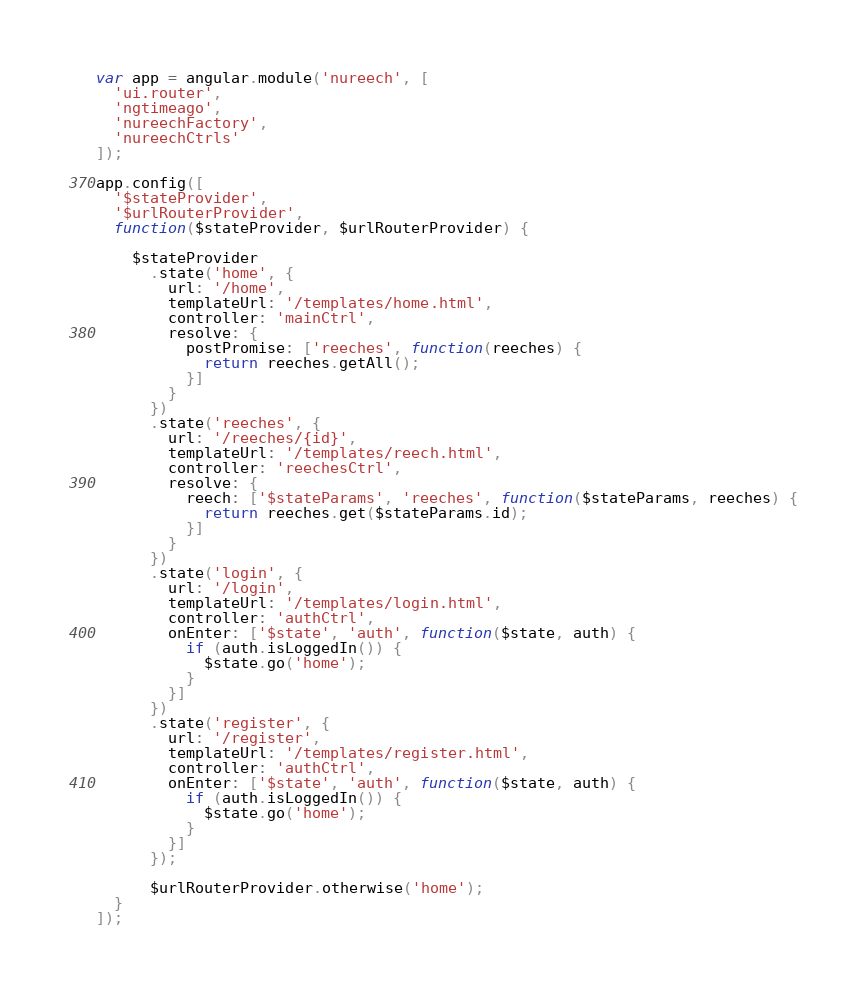Convert code to text. <code><loc_0><loc_0><loc_500><loc_500><_JavaScript_>var app = angular.module('nureech', [
  'ui.router',
  'ngtimeago',
  'nureechFactory',
  'nureechCtrls'
]);

app.config([
  '$stateProvider',
  '$urlRouterProvider',
  function($stateProvider, $urlRouterProvider) {

    $stateProvider
      .state('home', {
        url: '/home',
        templateUrl: '/templates/home.html',
        controller: 'mainCtrl',
        resolve: {
          postPromise: ['reeches', function(reeches) {
            return reeches.getAll();
          }]
        }
      })
      .state('reeches', {
        url: '/reeches/{id}',
        templateUrl: '/templates/reech.html',
        controller: 'reechesCtrl',
        resolve: {
          reech: ['$stateParams', 'reeches', function($stateParams, reeches) {
            return reeches.get($stateParams.id);
          }]
        }
      })
      .state('login', {
        url: '/login',
        templateUrl: '/templates/login.html',
        controller: 'authCtrl',
        onEnter: ['$state', 'auth', function($state, auth) {
          if (auth.isLoggedIn()) {
            $state.go('home');
          }
        }]
      })
      .state('register', {
        url: '/register',
        templateUrl: '/templates/register.html',
        controller: 'authCtrl',
        onEnter: ['$state', 'auth', function($state, auth) {
          if (auth.isLoggedIn()) {
            $state.go('home');
          }
        }]
      });

      $urlRouterProvider.otherwise('home');
  }
]);
</code> 